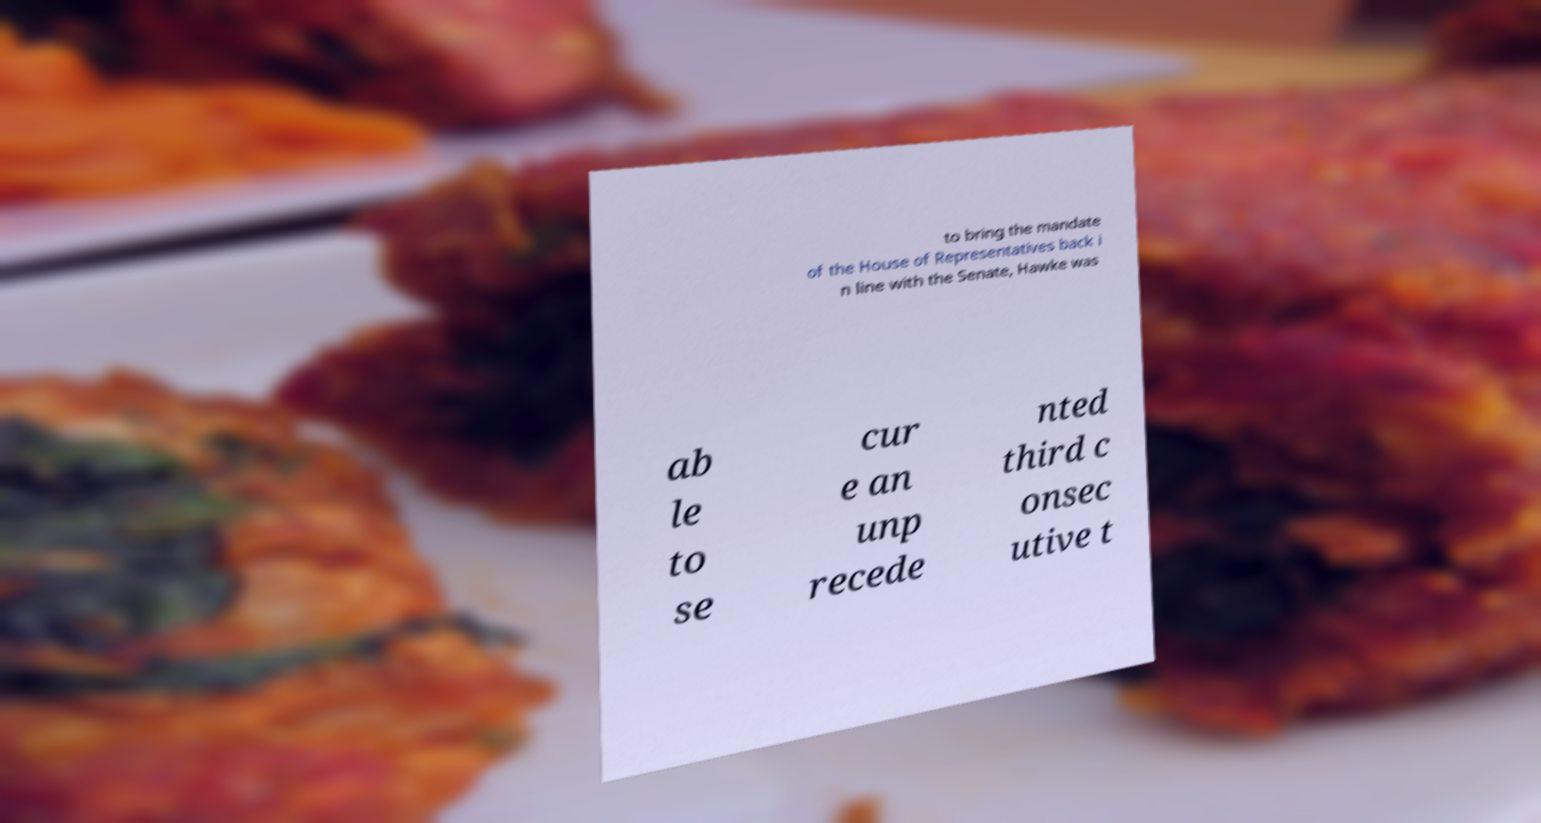What messages or text are displayed in this image? I need them in a readable, typed format. to bring the mandate of the House of Representatives back i n line with the Senate, Hawke was ab le to se cur e an unp recede nted third c onsec utive t 